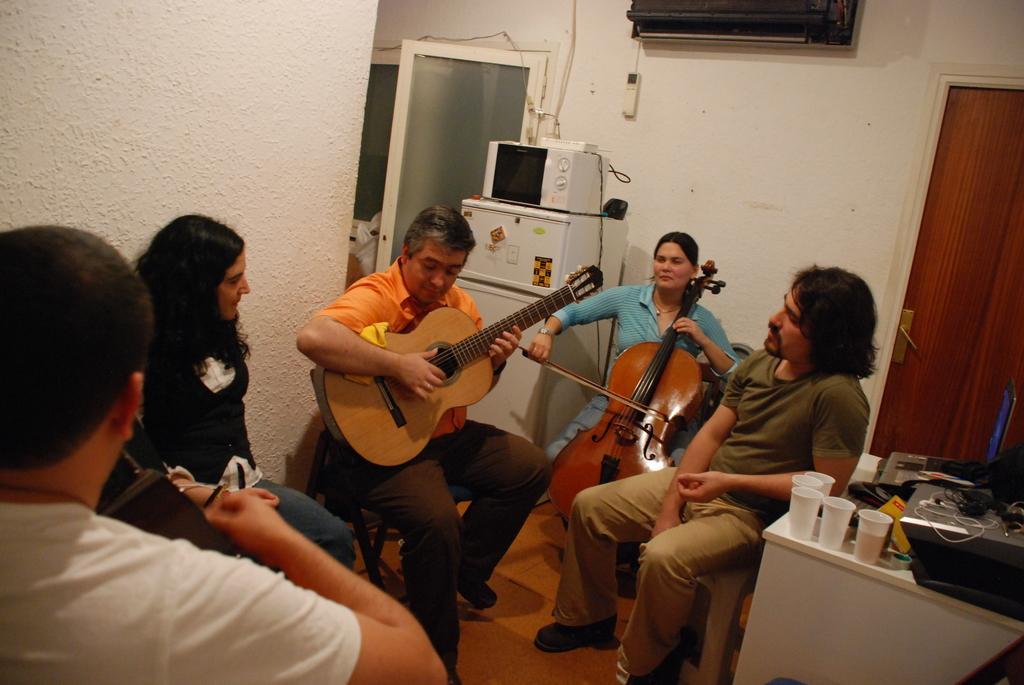Describe this image in one or two sentences. In the middle of the image few people are sitting and playing some musical instruments. Bottom right side of the image there is a table on the table there are some cups and there is a laptop. In the middle of the image there is a micro oven. Behind the micro oven there is a door. Top left side of the image there is a wall. 